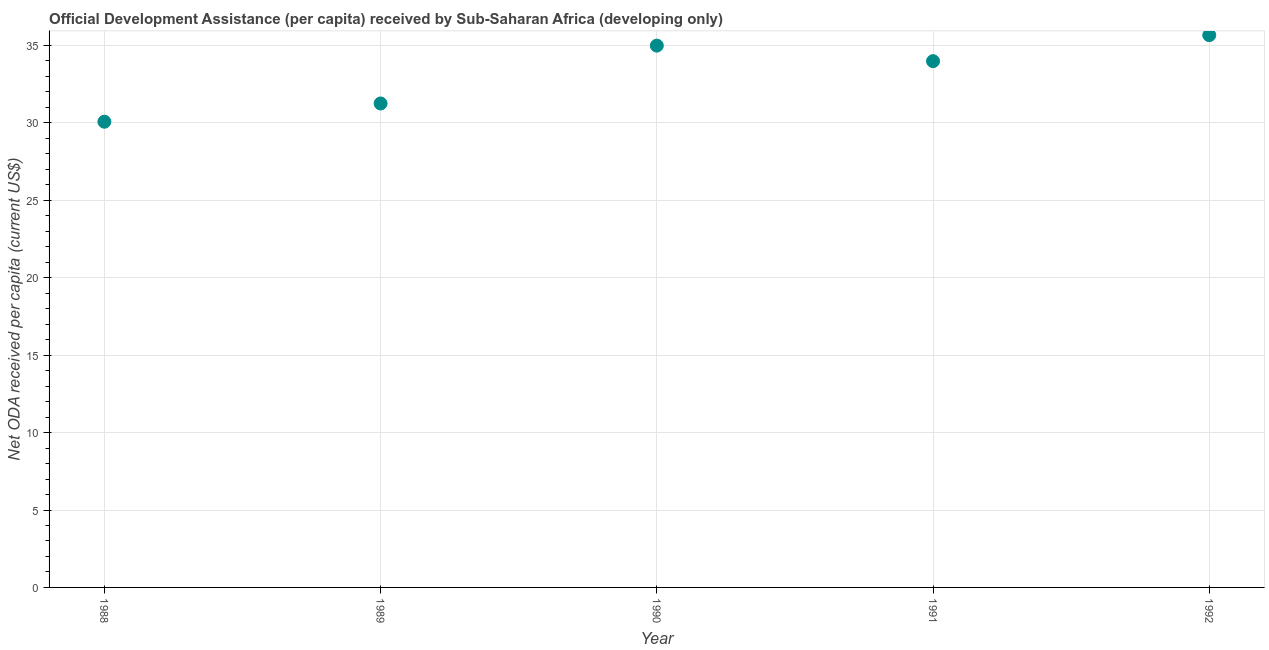What is the net oda received per capita in 1992?
Offer a very short reply. 35.67. Across all years, what is the maximum net oda received per capita?
Provide a short and direct response. 35.67. Across all years, what is the minimum net oda received per capita?
Ensure brevity in your answer.  30.08. In which year was the net oda received per capita maximum?
Your response must be concise. 1992. What is the sum of the net oda received per capita?
Your answer should be very brief. 165.98. What is the difference between the net oda received per capita in 1988 and 1991?
Offer a very short reply. -3.91. What is the average net oda received per capita per year?
Make the answer very short. 33.2. What is the median net oda received per capita?
Provide a succinct answer. 33.99. In how many years, is the net oda received per capita greater than 30 US$?
Offer a very short reply. 5. What is the ratio of the net oda received per capita in 1988 to that in 1990?
Make the answer very short. 0.86. Is the net oda received per capita in 1989 less than that in 1992?
Offer a very short reply. Yes. Is the difference between the net oda received per capita in 1988 and 1990 greater than the difference between any two years?
Offer a terse response. No. What is the difference between the highest and the second highest net oda received per capita?
Make the answer very short. 0.68. Is the sum of the net oda received per capita in 1989 and 1990 greater than the maximum net oda received per capita across all years?
Provide a short and direct response. Yes. What is the difference between the highest and the lowest net oda received per capita?
Make the answer very short. 5.59. In how many years, is the net oda received per capita greater than the average net oda received per capita taken over all years?
Your answer should be compact. 3. Does the net oda received per capita monotonically increase over the years?
Provide a short and direct response. No. How many dotlines are there?
Give a very brief answer. 1. What is the difference between two consecutive major ticks on the Y-axis?
Your response must be concise. 5. Are the values on the major ticks of Y-axis written in scientific E-notation?
Offer a very short reply. No. Does the graph contain any zero values?
Offer a terse response. No. Does the graph contain grids?
Your answer should be compact. Yes. What is the title of the graph?
Your answer should be compact. Official Development Assistance (per capita) received by Sub-Saharan Africa (developing only). What is the label or title of the X-axis?
Ensure brevity in your answer.  Year. What is the label or title of the Y-axis?
Keep it short and to the point. Net ODA received per capita (current US$). What is the Net ODA received per capita (current US$) in 1988?
Give a very brief answer. 30.08. What is the Net ODA received per capita (current US$) in 1989?
Keep it short and to the point. 31.26. What is the Net ODA received per capita (current US$) in 1990?
Keep it short and to the point. 34.99. What is the Net ODA received per capita (current US$) in 1991?
Offer a very short reply. 33.99. What is the Net ODA received per capita (current US$) in 1992?
Keep it short and to the point. 35.67. What is the difference between the Net ODA received per capita (current US$) in 1988 and 1989?
Make the answer very short. -1.18. What is the difference between the Net ODA received per capita (current US$) in 1988 and 1990?
Keep it short and to the point. -4.92. What is the difference between the Net ODA received per capita (current US$) in 1988 and 1991?
Make the answer very short. -3.91. What is the difference between the Net ODA received per capita (current US$) in 1988 and 1992?
Offer a very short reply. -5.59. What is the difference between the Net ODA received per capita (current US$) in 1989 and 1990?
Your answer should be compact. -3.74. What is the difference between the Net ODA received per capita (current US$) in 1989 and 1991?
Your answer should be very brief. -2.73. What is the difference between the Net ODA received per capita (current US$) in 1989 and 1992?
Your answer should be very brief. -4.41. What is the difference between the Net ODA received per capita (current US$) in 1990 and 1991?
Your response must be concise. 1. What is the difference between the Net ODA received per capita (current US$) in 1990 and 1992?
Provide a succinct answer. -0.68. What is the difference between the Net ODA received per capita (current US$) in 1991 and 1992?
Offer a terse response. -1.68. What is the ratio of the Net ODA received per capita (current US$) in 1988 to that in 1989?
Provide a short and direct response. 0.96. What is the ratio of the Net ODA received per capita (current US$) in 1988 to that in 1990?
Offer a very short reply. 0.86. What is the ratio of the Net ODA received per capita (current US$) in 1988 to that in 1991?
Your response must be concise. 0.89. What is the ratio of the Net ODA received per capita (current US$) in 1988 to that in 1992?
Give a very brief answer. 0.84. What is the ratio of the Net ODA received per capita (current US$) in 1989 to that in 1990?
Ensure brevity in your answer.  0.89. What is the ratio of the Net ODA received per capita (current US$) in 1989 to that in 1992?
Your answer should be very brief. 0.88. What is the ratio of the Net ODA received per capita (current US$) in 1990 to that in 1991?
Provide a short and direct response. 1.03. What is the ratio of the Net ODA received per capita (current US$) in 1991 to that in 1992?
Your response must be concise. 0.95. 